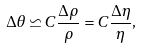Convert formula to latex. <formula><loc_0><loc_0><loc_500><loc_500>\Delta \theta \backsimeq C \frac { \Delta \rho } { \rho } = C \frac { \Delta \eta } { \eta } ,</formula> 